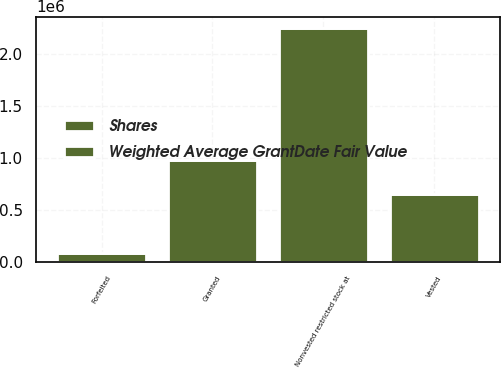Convert chart. <chart><loc_0><loc_0><loc_500><loc_500><stacked_bar_chart><ecel><fcel>Nonvested restricted stock at<fcel>Granted<fcel>Vested<fcel>Forfeited<nl><fcel>Shares<fcel>2.24283e+06<fcel>978064<fcel>656054<fcel>86484<nl><fcel>Weighted Average GrantDate Fair Value<fcel>55.44<fcel>41.16<fcel>54.34<fcel>57.46<nl></chart> 